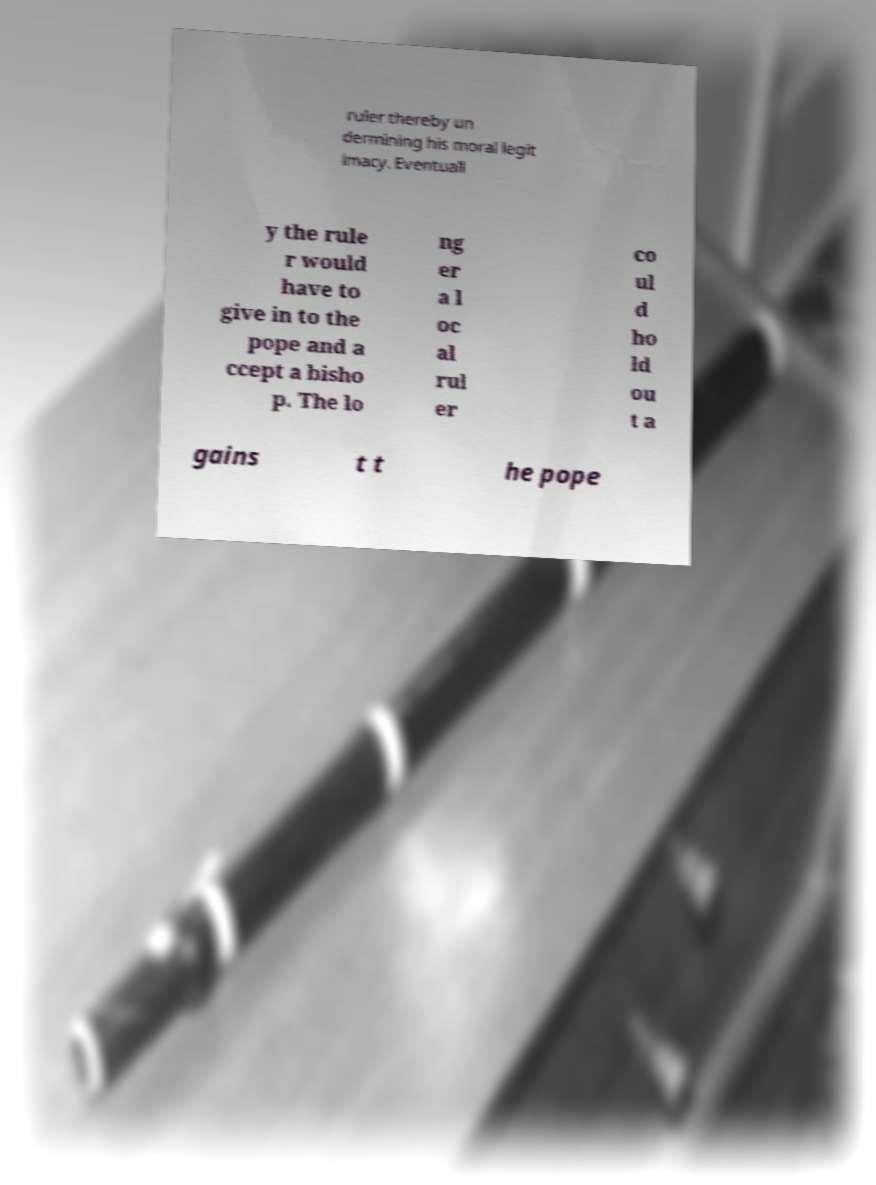For documentation purposes, I need the text within this image transcribed. Could you provide that? ruler thereby un dermining his moral legit imacy. Eventuall y the rule r would have to give in to the pope and a ccept a bisho p. The lo ng er a l oc al rul er co ul d ho ld ou t a gains t t he pope 